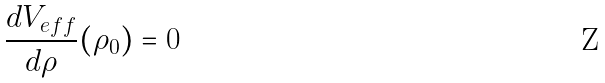Convert formula to latex. <formula><loc_0><loc_0><loc_500><loc_500>\frac { d V _ { e f f } } { d \rho } ( \rho _ { 0 } ) = 0</formula> 